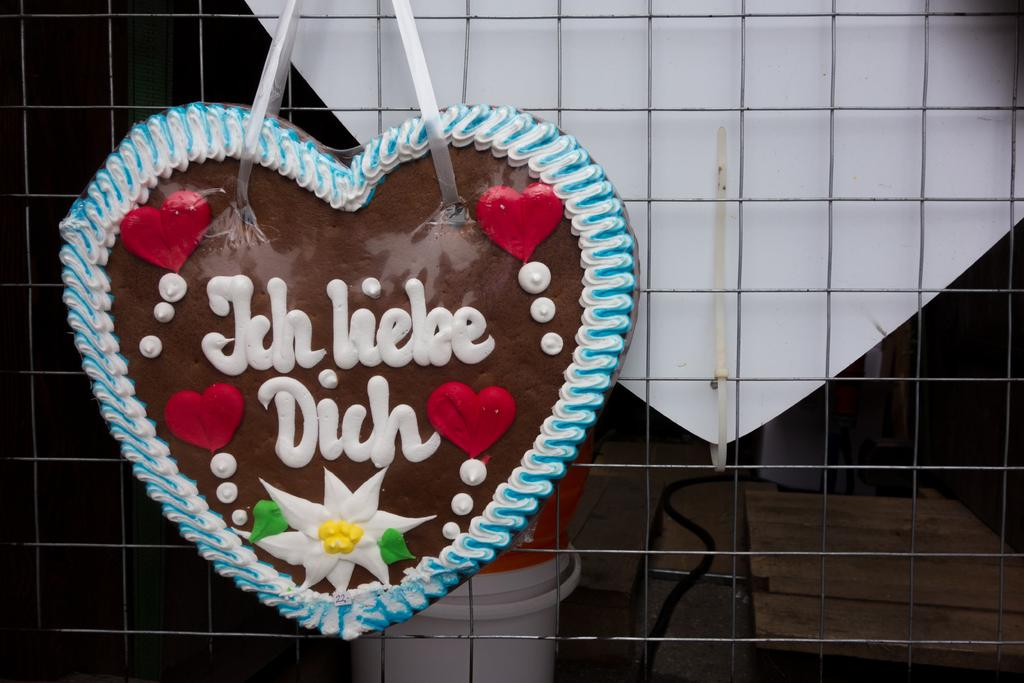What is the main subject of the image? There is a cake-like structure in the image. How is the cake-like structure connected to another object? The cake-like structure is attached to a net. What can be said about the appearance of the cake? The cake is colorful. What is visible in the background of the image? There is a white color board and a bucket in the background of the image. What role does the father play in the image? There is no mention of a father or any person in the image, so it is impossible to determine any role they might play. Is the cake-like structure sinking in quicksand in the image? There is no quicksand present in the image, and the cake-like structure is attached to a net, not sinking. 